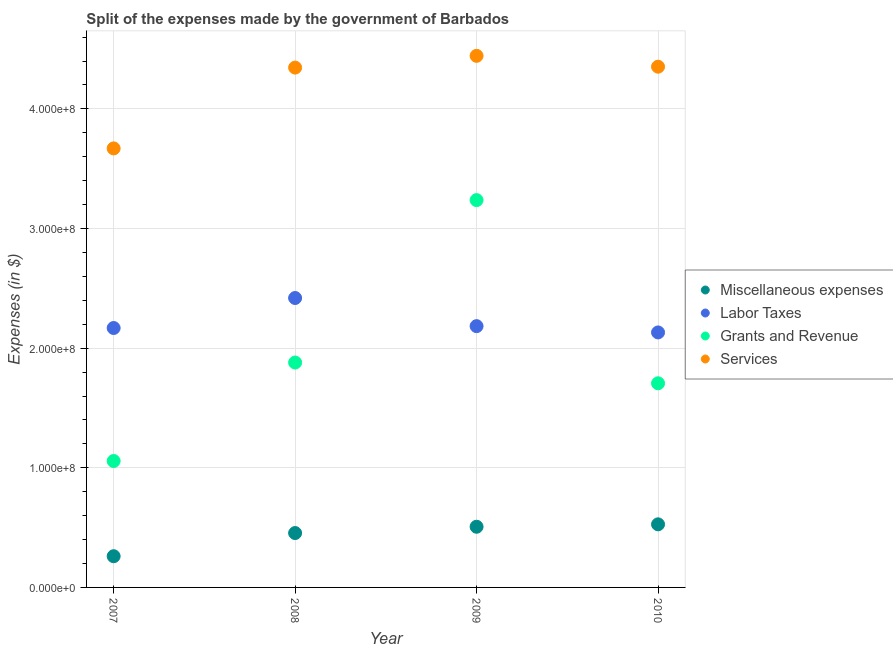What is the amount spent on services in 2009?
Offer a terse response. 4.44e+08. Across all years, what is the maximum amount spent on grants and revenue?
Provide a short and direct response. 3.24e+08. Across all years, what is the minimum amount spent on grants and revenue?
Offer a very short reply. 1.06e+08. What is the total amount spent on labor taxes in the graph?
Make the answer very short. 8.90e+08. What is the difference between the amount spent on services in 2007 and that in 2010?
Provide a short and direct response. -6.83e+07. What is the difference between the amount spent on grants and revenue in 2007 and the amount spent on services in 2008?
Your answer should be very brief. -3.29e+08. What is the average amount spent on grants and revenue per year?
Give a very brief answer. 1.97e+08. In the year 2009, what is the difference between the amount spent on miscellaneous expenses and amount spent on grants and revenue?
Your answer should be compact. -2.73e+08. In how many years, is the amount spent on grants and revenue greater than 320000000 $?
Keep it short and to the point. 1. What is the ratio of the amount spent on services in 2008 to that in 2009?
Provide a succinct answer. 0.98. Is the amount spent on grants and revenue in 2008 less than that in 2009?
Offer a terse response. Yes. Is the difference between the amount spent on grants and revenue in 2009 and 2010 greater than the difference between the amount spent on labor taxes in 2009 and 2010?
Give a very brief answer. Yes. What is the difference between the highest and the second highest amount spent on labor taxes?
Give a very brief answer. 2.35e+07. What is the difference between the highest and the lowest amount spent on miscellaneous expenses?
Keep it short and to the point. 2.66e+07. Is it the case that in every year, the sum of the amount spent on grants and revenue and amount spent on services is greater than the sum of amount spent on miscellaneous expenses and amount spent on labor taxes?
Keep it short and to the point. Yes. Is the amount spent on grants and revenue strictly less than the amount spent on miscellaneous expenses over the years?
Your answer should be compact. No. How many years are there in the graph?
Provide a succinct answer. 4. What is the difference between two consecutive major ticks on the Y-axis?
Offer a terse response. 1.00e+08. Does the graph contain any zero values?
Ensure brevity in your answer.  No. Does the graph contain grids?
Make the answer very short. Yes. Where does the legend appear in the graph?
Keep it short and to the point. Center right. How many legend labels are there?
Ensure brevity in your answer.  4. How are the legend labels stacked?
Your answer should be compact. Vertical. What is the title of the graph?
Your answer should be very brief. Split of the expenses made by the government of Barbados. Does "Fiscal policy" appear as one of the legend labels in the graph?
Your answer should be compact. No. What is the label or title of the Y-axis?
Offer a very short reply. Expenses (in $). What is the Expenses (in $) in Miscellaneous expenses in 2007?
Make the answer very short. 2.61e+07. What is the Expenses (in $) of Labor Taxes in 2007?
Keep it short and to the point. 2.17e+08. What is the Expenses (in $) of Grants and Revenue in 2007?
Give a very brief answer. 1.06e+08. What is the Expenses (in $) in Services in 2007?
Keep it short and to the point. 3.67e+08. What is the Expenses (in $) in Miscellaneous expenses in 2008?
Ensure brevity in your answer.  4.55e+07. What is the Expenses (in $) of Labor Taxes in 2008?
Your answer should be compact. 2.42e+08. What is the Expenses (in $) of Grants and Revenue in 2008?
Ensure brevity in your answer.  1.88e+08. What is the Expenses (in $) in Services in 2008?
Make the answer very short. 4.35e+08. What is the Expenses (in $) in Miscellaneous expenses in 2009?
Offer a terse response. 5.07e+07. What is the Expenses (in $) of Labor Taxes in 2009?
Ensure brevity in your answer.  2.18e+08. What is the Expenses (in $) of Grants and Revenue in 2009?
Your answer should be compact. 3.24e+08. What is the Expenses (in $) of Services in 2009?
Ensure brevity in your answer.  4.44e+08. What is the Expenses (in $) of Miscellaneous expenses in 2010?
Your answer should be very brief. 5.27e+07. What is the Expenses (in $) of Labor Taxes in 2010?
Offer a terse response. 2.13e+08. What is the Expenses (in $) in Grants and Revenue in 2010?
Your answer should be very brief. 1.71e+08. What is the Expenses (in $) of Services in 2010?
Provide a short and direct response. 4.35e+08. Across all years, what is the maximum Expenses (in $) of Miscellaneous expenses?
Provide a succinct answer. 5.27e+07. Across all years, what is the maximum Expenses (in $) in Labor Taxes?
Your answer should be very brief. 2.42e+08. Across all years, what is the maximum Expenses (in $) of Grants and Revenue?
Provide a succinct answer. 3.24e+08. Across all years, what is the maximum Expenses (in $) in Services?
Ensure brevity in your answer.  4.44e+08. Across all years, what is the minimum Expenses (in $) in Miscellaneous expenses?
Give a very brief answer. 2.61e+07. Across all years, what is the minimum Expenses (in $) in Labor Taxes?
Make the answer very short. 2.13e+08. Across all years, what is the minimum Expenses (in $) of Grants and Revenue?
Your answer should be very brief. 1.06e+08. Across all years, what is the minimum Expenses (in $) of Services?
Your answer should be compact. 3.67e+08. What is the total Expenses (in $) of Miscellaneous expenses in the graph?
Ensure brevity in your answer.  1.75e+08. What is the total Expenses (in $) of Labor Taxes in the graph?
Make the answer very short. 8.90e+08. What is the total Expenses (in $) of Grants and Revenue in the graph?
Ensure brevity in your answer.  7.88e+08. What is the total Expenses (in $) of Services in the graph?
Offer a very short reply. 1.68e+09. What is the difference between the Expenses (in $) in Miscellaneous expenses in 2007 and that in 2008?
Offer a very short reply. -1.94e+07. What is the difference between the Expenses (in $) of Labor Taxes in 2007 and that in 2008?
Offer a terse response. -2.51e+07. What is the difference between the Expenses (in $) of Grants and Revenue in 2007 and that in 2008?
Your answer should be compact. -8.23e+07. What is the difference between the Expenses (in $) of Services in 2007 and that in 2008?
Give a very brief answer. -6.75e+07. What is the difference between the Expenses (in $) of Miscellaneous expenses in 2007 and that in 2009?
Your answer should be compact. -2.46e+07. What is the difference between the Expenses (in $) in Labor Taxes in 2007 and that in 2009?
Provide a succinct answer. -1.56e+06. What is the difference between the Expenses (in $) in Grants and Revenue in 2007 and that in 2009?
Provide a succinct answer. -2.18e+08. What is the difference between the Expenses (in $) in Services in 2007 and that in 2009?
Provide a short and direct response. -7.74e+07. What is the difference between the Expenses (in $) of Miscellaneous expenses in 2007 and that in 2010?
Give a very brief answer. -2.66e+07. What is the difference between the Expenses (in $) of Labor Taxes in 2007 and that in 2010?
Make the answer very short. 3.69e+06. What is the difference between the Expenses (in $) in Grants and Revenue in 2007 and that in 2010?
Your answer should be compact. -6.50e+07. What is the difference between the Expenses (in $) in Services in 2007 and that in 2010?
Your answer should be compact. -6.83e+07. What is the difference between the Expenses (in $) of Miscellaneous expenses in 2008 and that in 2009?
Provide a short and direct response. -5.27e+06. What is the difference between the Expenses (in $) in Labor Taxes in 2008 and that in 2009?
Give a very brief answer. 2.35e+07. What is the difference between the Expenses (in $) in Grants and Revenue in 2008 and that in 2009?
Offer a very short reply. -1.36e+08. What is the difference between the Expenses (in $) in Services in 2008 and that in 2009?
Offer a very short reply. -9.82e+06. What is the difference between the Expenses (in $) in Miscellaneous expenses in 2008 and that in 2010?
Provide a short and direct response. -7.29e+06. What is the difference between the Expenses (in $) of Labor Taxes in 2008 and that in 2010?
Offer a very short reply. 2.88e+07. What is the difference between the Expenses (in $) of Grants and Revenue in 2008 and that in 2010?
Make the answer very short. 1.73e+07. What is the difference between the Expenses (in $) of Services in 2008 and that in 2010?
Your answer should be compact. -7.51e+05. What is the difference between the Expenses (in $) of Miscellaneous expenses in 2009 and that in 2010?
Offer a terse response. -2.02e+06. What is the difference between the Expenses (in $) of Labor Taxes in 2009 and that in 2010?
Offer a very short reply. 5.25e+06. What is the difference between the Expenses (in $) in Grants and Revenue in 2009 and that in 2010?
Ensure brevity in your answer.  1.53e+08. What is the difference between the Expenses (in $) in Services in 2009 and that in 2010?
Keep it short and to the point. 9.07e+06. What is the difference between the Expenses (in $) in Miscellaneous expenses in 2007 and the Expenses (in $) in Labor Taxes in 2008?
Keep it short and to the point. -2.16e+08. What is the difference between the Expenses (in $) in Miscellaneous expenses in 2007 and the Expenses (in $) in Grants and Revenue in 2008?
Your response must be concise. -1.62e+08. What is the difference between the Expenses (in $) of Miscellaneous expenses in 2007 and the Expenses (in $) of Services in 2008?
Your answer should be compact. -4.08e+08. What is the difference between the Expenses (in $) of Labor Taxes in 2007 and the Expenses (in $) of Grants and Revenue in 2008?
Keep it short and to the point. 2.89e+07. What is the difference between the Expenses (in $) in Labor Taxes in 2007 and the Expenses (in $) in Services in 2008?
Offer a terse response. -2.18e+08. What is the difference between the Expenses (in $) in Grants and Revenue in 2007 and the Expenses (in $) in Services in 2008?
Keep it short and to the point. -3.29e+08. What is the difference between the Expenses (in $) in Miscellaneous expenses in 2007 and the Expenses (in $) in Labor Taxes in 2009?
Your answer should be compact. -1.92e+08. What is the difference between the Expenses (in $) in Miscellaneous expenses in 2007 and the Expenses (in $) in Grants and Revenue in 2009?
Ensure brevity in your answer.  -2.98e+08. What is the difference between the Expenses (in $) of Miscellaneous expenses in 2007 and the Expenses (in $) of Services in 2009?
Make the answer very short. -4.18e+08. What is the difference between the Expenses (in $) in Labor Taxes in 2007 and the Expenses (in $) in Grants and Revenue in 2009?
Offer a terse response. -1.07e+08. What is the difference between the Expenses (in $) of Labor Taxes in 2007 and the Expenses (in $) of Services in 2009?
Your answer should be very brief. -2.28e+08. What is the difference between the Expenses (in $) in Grants and Revenue in 2007 and the Expenses (in $) in Services in 2009?
Your response must be concise. -3.39e+08. What is the difference between the Expenses (in $) of Miscellaneous expenses in 2007 and the Expenses (in $) of Labor Taxes in 2010?
Provide a short and direct response. -1.87e+08. What is the difference between the Expenses (in $) in Miscellaneous expenses in 2007 and the Expenses (in $) in Grants and Revenue in 2010?
Offer a very short reply. -1.45e+08. What is the difference between the Expenses (in $) of Miscellaneous expenses in 2007 and the Expenses (in $) of Services in 2010?
Offer a terse response. -4.09e+08. What is the difference between the Expenses (in $) of Labor Taxes in 2007 and the Expenses (in $) of Grants and Revenue in 2010?
Offer a very short reply. 4.62e+07. What is the difference between the Expenses (in $) of Labor Taxes in 2007 and the Expenses (in $) of Services in 2010?
Make the answer very short. -2.18e+08. What is the difference between the Expenses (in $) of Grants and Revenue in 2007 and the Expenses (in $) of Services in 2010?
Give a very brief answer. -3.30e+08. What is the difference between the Expenses (in $) of Miscellaneous expenses in 2008 and the Expenses (in $) of Labor Taxes in 2009?
Give a very brief answer. -1.73e+08. What is the difference between the Expenses (in $) in Miscellaneous expenses in 2008 and the Expenses (in $) in Grants and Revenue in 2009?
Give a very brief answer. -2.78e+08. What is the difference between the Expenses (in $) in Miscellaneous expenses in 2008 and the Expenses (in $) in Services in 2009?
Provide a short and direct response. -3.99e+08. What is the difference between the Expenses (in $) of Labor Taxes in 2008 and the Expenses (in $) of Grants and Revenue in 2009?
Make the answer very short. -8.18e+07. What is the difference between the Expenses (in $) of Labor Taxes in 2008 and the Expenses (in $) of Services in 2009?
Provide a short and direct response. -2.02e+08. What is the difference between the Expenses (in $) of Grants and Revenue in 2008 and the Expenses (in $) of Services in 2009?
Your answer should be very brief. -2.56e+08. What is the difference between the Expenses (in $) in Miscellaneous expenses in 2008 and the Expenses (in $) in Labor Taxes in 2010?
Your answer should be very brief. -1.68e+08. What is the difference between the Expenses (in $) of Miscellaneous expenses in 2008 and the Expenses (in $) of Grants and Revenue in 2010?
Offer a very short reply. -1.25e+08. What is the difference between the Expenses (in $) in Miscellaneous expenses in 2008 and the Expenses (in $) in Services in 2010?
Provide a succinct answer. -3.90e+08. What is the difference between the Expenses (in $) in Labor Taxes in 2008 and the Expenses (in $) in Grants and Revenue in 2010?
Give a very brief answer. 7.13e+07. What is the difference between the Expenses (in $) in Labor Taxes in 2008 and the Expenses (in $) in Services in 2010?
Provide a short and direct response. -1.93e+08. What is the difference between the Expenses (in $) of Grants and Revenue in 2008 and the Expenses (in $) of Services in 2010?
Provide a short and direct response. -2.47e+08. What is the difference between the Expenses (in $) in Miscellaneous expenses in 2009 and the Expenses (in $) in Labor Taxes in 2010?
Keep it short and to the point. -1.62e+08. What is the difference between the Expenses (in $) of Miscellaneous expenses in 2009 and the Expenses (in $) of Grants and Revenue in 2010?
Provide a short and direct response. -1.20e+08. What is the difference between the Expenses (in $) in Miscellaneous expenses in 2009 and the Expenses (in $) in Services in 2010?
Give a very brief answer. -3.85e+08. What is the difference between the Expenses (in $) of Labor Taxes in 2009 and the Expenses (in $) of Grants and Revenue in 2010?
Keep it short and to the point. 4.78e+07. What is the difference between the Expenses (in $) of Labor Taxes in 2009 and the Expenses (in $) of Services in 2010?
Your answer should be compact. -2.17e+08. What is the difference between the Expenses (in $) in Grants and Revenue in 2009 and the Expenses (in $) in Services in 2010?
Give a very brief answer. -1.12e+08. What is the average Expenses (in $) in Miscellaneous expenses per year?
Offer a terse response. 4.38e+07. What is the average Expenses (in $) of Labor Taxes per year?
Make the answer very short. 2.23e+08. What is the average Expenses (in $) in Grants and Revenue per year?
Your answer should be compact. 1.97e+08. What is the average Expenses (in $) of Services per year?
Offer a very short reply. 4.20e+08. In the year 2007, what is the difference between the Expenses (in $) in Miscellaneous expenses and Expenses (in $) in Labor Taxes?
Your response must be concise. -1.91e+08. In the year 2007, what is the difference between the Expenses (in $) of Miscellaneous expenses and Expenses (in $) of Grants and Revenue?
Ensure brevity in your answer.  -7.96e+07. In the year 2007, what is the difference between the Expenses (in $) in Miscellaneous expenses and Expenses (in $) in Services?
Keep it short and to the point. -3.41e+08. In the year 2007, what is the difference between the Expenses (in $) in Labor Taxes and Expenses (in $) in Grants and Revenue?
Your answer should be compact. 1.11e+08. In the year 2007, what is the difference between the Expenses (in $) of Labor Taxes and Expenses (in $) of Services?
Give a very brief answer. -1.50e+08. In the year 2007, what is the difference between the Expenses (in $) of Grants and Revenue and Expenses (in $) of Services?
Make the answer very short. -2.61e+08. In the year 2008, what is the difference between the Expenses (in $) in Miscellaneous expenses and Expenses (in $) in Labor Taxes?
Your answer should be very brief. -1.96e+08. In the year 2008, what is the difference between the Expenses (in $) in Miscellaneous expenses and Expenses (in $) in Grants and Revenue?
Make the answer very short. -1.43e+08. In the year 2008, what is the difference between the Expenses (in $) in Miscellaneous expenses and Expenses (in $) in Services?
Your answer should be compact. -3.89e+08. In the year 2008, what is the difference between the Expenses (in $) of Labor Taxes and Expenses (in $) of Grants and Revenue?
Offer a very short reply. 5.39e+07. In the year 2008, what is the difference between the Expenses (in $) of Labor Taxes and Expenses (in $) of Services?
Offer a terse response. -1.93e+08. In the year 2008, what is the difference between the Expenses (in $) in Grants and Revenue and Expenses (in $) in Services?
Your answer should be very brief. -2.47e+08. In the year 2009, what is the difference between the Expenses (in $) in Miscellaneous expenses and Expenses (in $) in Labor Taxes?
Make the answer very short. -1.68e+08. In the year 2009, what is the difference between the Expenses (in $) of Miscellaneous expenses and Expenses (in $) of Grants and Revenue?
Offer a very short reply. -2.73e+08. In the year 2009, what is the difference between the Expenses (in $) of Miscellaneous expenses and Expenses (in $) of Services?
Provide a short and direct response. -3.94e+08. In the year 2009, what is the difference between the Expenses (in $) in Labor Taxes and Expenses (in $) in Grants and Revenue?
Your answer should be very brief. -1.05e+08. In the year 2009, what is the difference between the Expenses (in $) in Labor Taxes and Expenses (in $) in Services?
Your answer should be compact. -2.26e+08. In the year 2009, what is the difference between the Expenses (in $) in Grants and Revenue and Expenses (in $) in Services?
Keep it short and to the point. -1.21e+08. In the year 2010, what is the difference between the Expenses (in $) of Miscellaneous expenses and Expenses (in $) of Labor Taxes?
Provide a succinct answer. -1.60e+08. In the year 2010, what is the difference between the Expenses (in $) of Miscellaneous expenses and Expenses (in $) of Grants and Revenue?
Your response must be concise. -1.18e+08. In the year 2010, what is the difference between the Expenses (in $) in Miscellaneous expenses and Expenses (in $) in Services?
Provide a short and direct response. -3.83e+08. In the year 2010, what is the difference between the Expenses (in $) of Labor Taxes and Expenses (in $) of Grants and Revenue?
Offer a terse response. 4.25e+07. In the year 2010, what is the difference between the Expenses (in $) of Labor Taxes and Expenses (in $) of Services?
Your answer should be compact. -2.22e+08. In the year 2010, what is the difference between the Expenses (in $) of Grants and Revenue and Expenses (in $) of Services?
Your answer should be very brief. -2.65e+08. What is the ratio of the Expenses (in $) in Miscellaneous expenses in 2007 to that in 2008?
Offer a very short reply. 0.57. What is the ratio of the Expenses (in $) of Labor Taxes in 2007 to that in 2008?
Provide a short and direct response. 0.9. What is the ratio of the Expenses (in $) in Grants and Revenue in 2007 to that in 2008?
Your response must be concise. 0.56. What is the ratio of the Expenses (in $) in Services in 2007 to that in 2008?
Give a very brief answer. 0.84. What is the ratio of the Expenses (in $) of Miscellaneous expenses in 2007 to that in 2009?
Your answer should be very brief. 0.51. What is the ratio of the Expenses (in $) in Labor Taxes in 2007 to that in 2009?
Your response must be concise. 0.99. What is the ratio of the Expenses (in $) in Grants and Revenue in 2007 to that in 2009?
Provide a succinct answer. 0.33. What is the ratio of the Expenses (in $) of Services in 2007 to that in 2009?
Offer a very short reply. 0.83. What is the ratio of the Expenses (in $) in Miscellaneous expenses in 2007 to that in 2010?
Make the answer very short. 0.49. What is the ratio of the Expenses (in $) of Labor Taxes in 2007 to that in 2010?
Offer a terse response. 1.02. What is the ratio of the Expenses (in $) in Grants and Revenue in 2007 to that in 2010?
Offer a terse response. 0.62. What is the ratio of the Expenses (in $) of Services in 2007 to that in 2010?
Provide a succinct answer. 0.84. What is the ratio of the Expenses (in $) in Miscellaneous expenses in 2008 to that in 2009?
Make the answer very short. 0.9. What is the ratio of the Expenses (in $) in Labor Taxes in 2008 to that in 2009?
Offer a very short reply. 1.11. What is the ratio of the Expenses (in $) in Grants and Revenue in 2008 to that in 2009?
Your answer should be compact. 0.58. What is the ratio of the Expenses (in $) of Services in 2008 to that in 2009?
Make the answer very short. 0.98. What is the ratio of the Expenses (in $) of Miscellaneous expenses in 2008 to that in 2010?
Your response must be concise. 0.86. What is the ratio of the Expenses (in $) in Labor Taxes in 2008 to that in 2010?
Provide a short and direct response. 1.14. What is the ratio of the Expenses (in $) in Grants and Revenue in 2008 to that in 2010?
Give a very brief answer. 1.1. What is the ratio of the Expenses (in $) of Services in 2008 to that in 2010?
Provide a succinct answer. 1. What is the ratio of the Expenses (in $) of Miscellaneous expenses in 2009 to that in 2010?
Your answer should be very brief. 0.96. What is the ratio of the Expenses (in $) in Labor Taxes in 2009 to that in 2010?
Make the answer very short. 1.02. What is the ratio of the Expenses (in $) in Grants and Revenue in 2009 to that in 2010?
Offer a very short reply. 1.9. What is the ratio of the Expenses (in $) of Services in 2009 to that in 2010?
Ensure brevity in your answer.  1.02. What is the difference between the highest and the second highest Expenses (in $) of Miscellaneous expenses?
Offer a very short reply. 2.02e+06. What is the difference between the highest and the second highest Expenses (in $) in Labor Taxes?
Ensure brevity in your answer.  2.35e+07. What is the difference between the highest and the second highest Expenses (in $) of Grants and Revenue?
Your response must be concise. 1.36e+08. What is the difference between the highest and the second highest Expenses (in $) of Services?
Your answer should be compact. 9.07e+06. What is the difference between the highest and the lowest Expenses (in $) in Miscellaneous expenses?
Provide a short and direct response. 2.66e+07. What is the difference between the highest and the lowest Expenses (in $) in Labor Taxes?
Offer a very short reply. 2.88e+07. What is the difference between the highest and the lowest Expenses (in $) in Grants and Revenue?
Your answer should be compact. 2.18e+08. What is the difference between the highest and the lowest Expenses (in $) of Services?
Make the answer very short. 7.74e+07. 